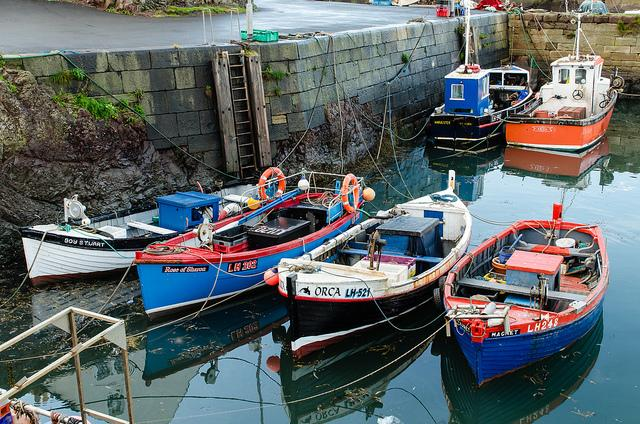What is available to get from the boats to the ground level? Please explain your reasoning. ladder. Ladders can help people raise the boats. 